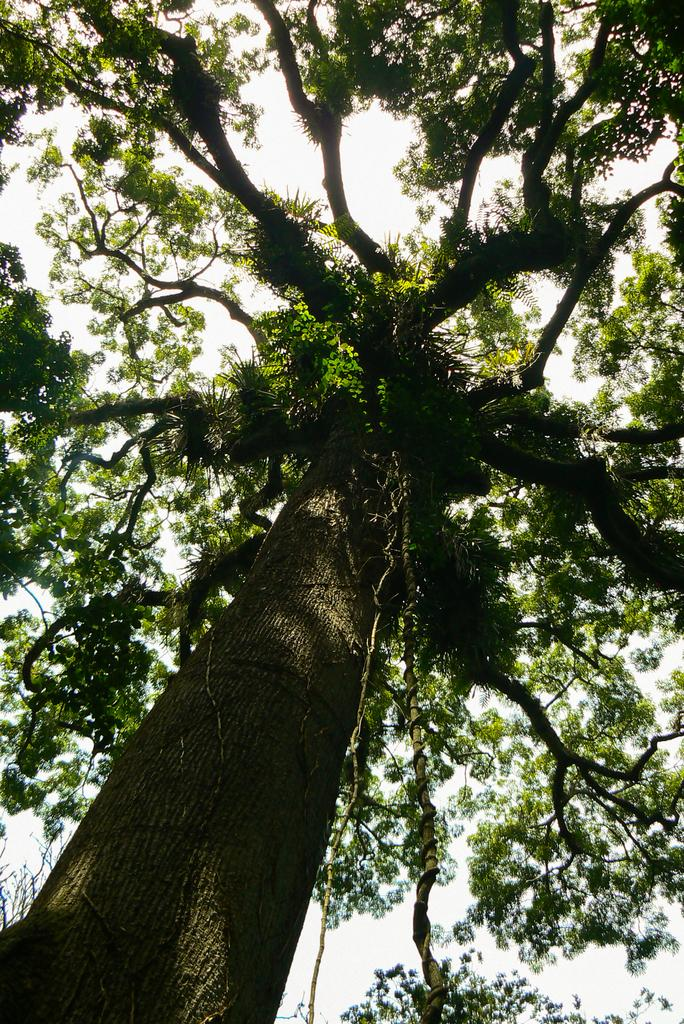What type of plant can be seen in the image? There is a tree in the image. What part of the natural environment is visible in the background of the image? The sky is visible in the background of the image. What part of the tree is visible at the bottom of the image? Tree branches are present at the bottom of the image. How many sheep are visible in the image? There are no sheep present in the image. What type of pipe is connected to the tree in the image? There is no pipe connected to the tree in the image. 